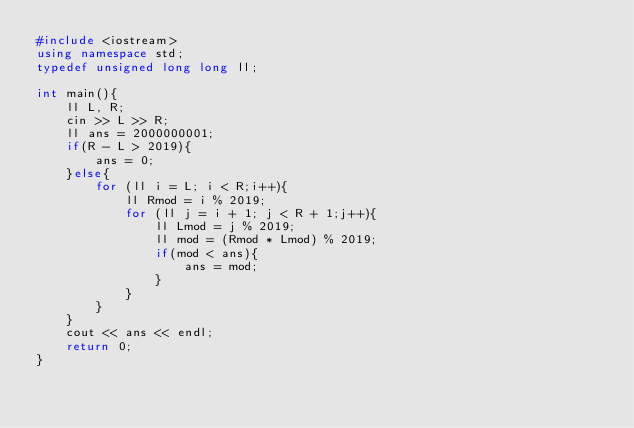Convert code to text. <code><loc_0><loc_0><loc_500><loc_500><_C++_>#include <iostream>
using namespace std;
typedef unsigned long long ll;

int main(){
    ll L, R;
    cin >> L >> R;
    ll ans = 2000000001;
    if(R - L > 2019){
        ans = 0;
    }else{
        for (ll i = L; i < R;i++){
            ll Rmod = i % 2019;
            for (ll j = i + 1; j < R + 1;j++){
                ll Lmod = j % 2019;
                ll mod = (Rmod * Lmod) % 2019;
                if(mod < ans){
                    ans = mod;
                }
            }
        }
    }
    cout << ans << endl;
    return 0;
}</code> 